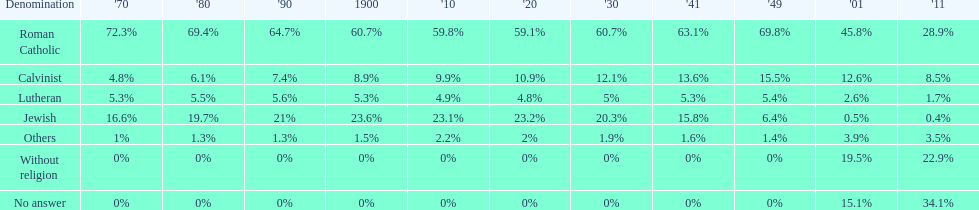Which religious denomination had a higher percentage in 1900, jewish or roman catholic? Roman Catholic. 